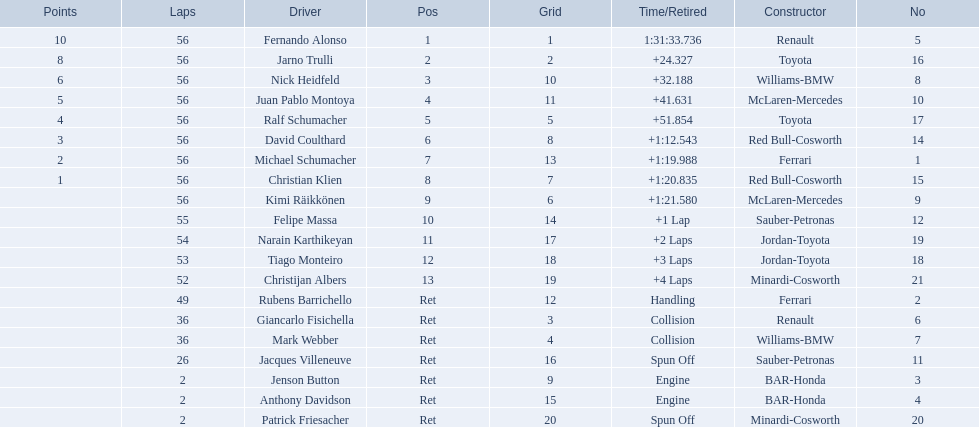Who was fernando alonso's instructor? Renault. How many laps did fernando alonso run? 56. How long did it take alonso to complete the race? 1:31:33.736. 